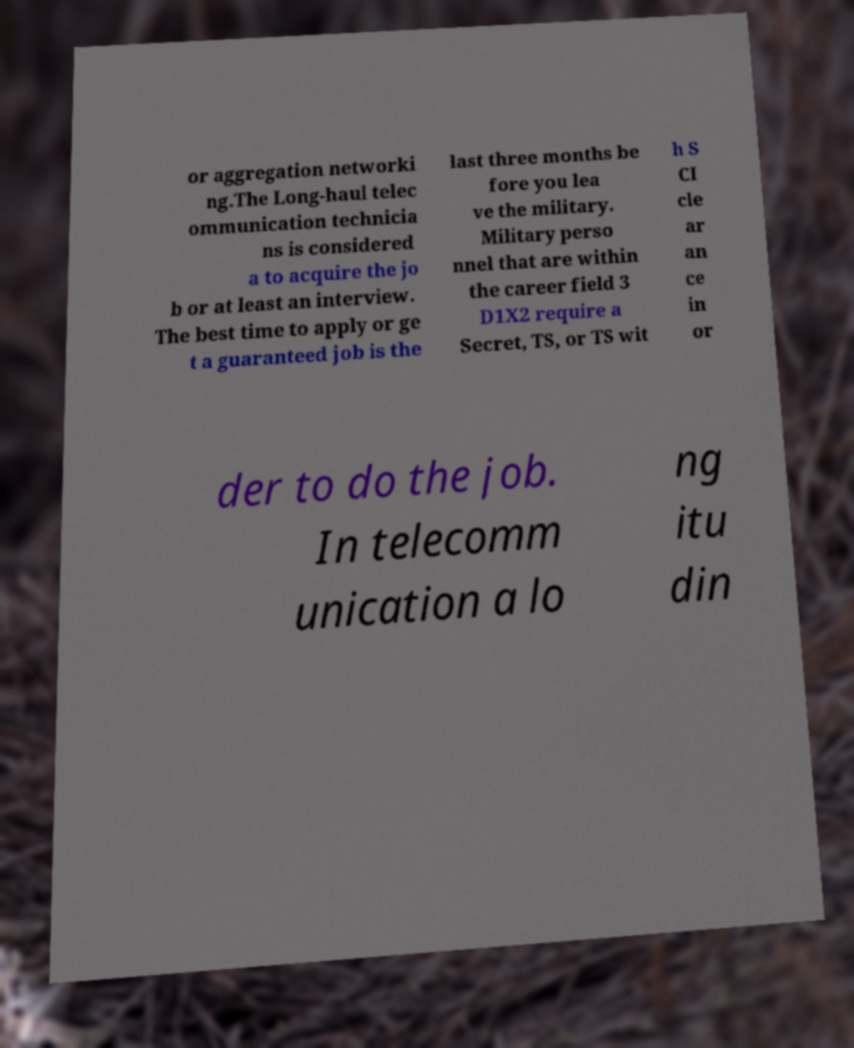Please read and relay the text visible in this image. What does it say? or aggregation networki ng.The Long-haul telec ommunication technicia ns is considered a to acquire the jo b or at least an interview. The best time to apply or ge t a guaranteed job is the last three months be fore you lea ve the military. Military perso nnel that are within the career field 3 D1X2 require a Secret, TS, or TS wit h S CI cle ar an ce in or der to do the job. In telecomm unication a lo ng itu din 